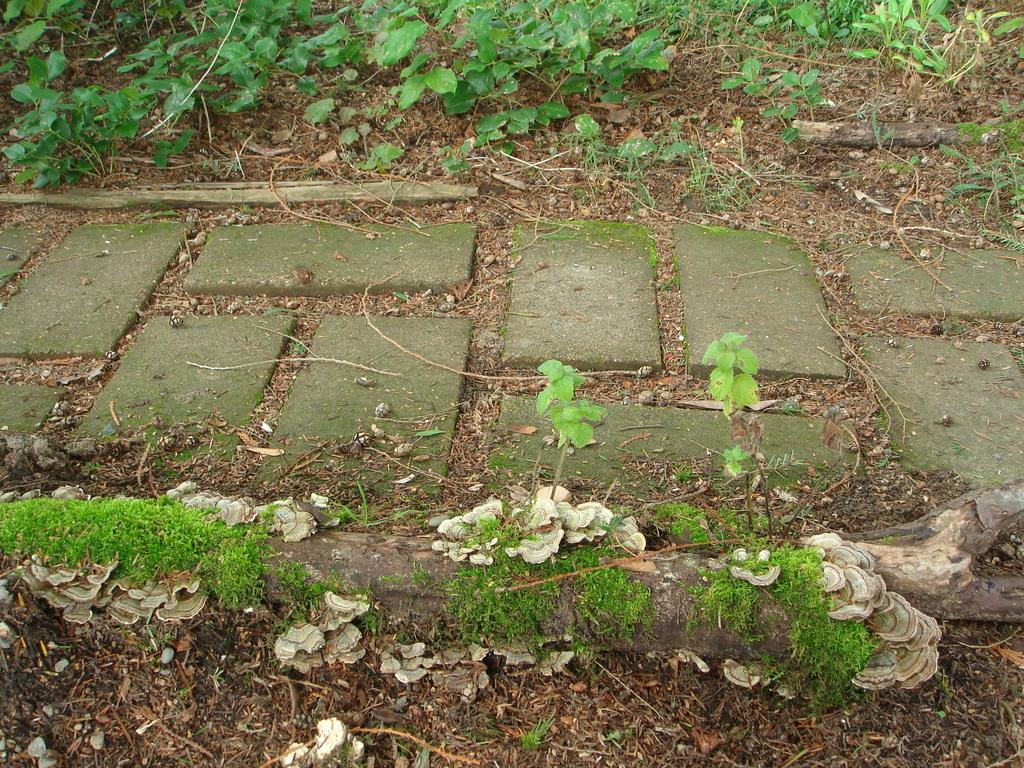What type of path is visible in the image? There is a walkway in the image. What can be seen growing in the image? There are plants in the image. What is present on the ground in the image? Dried leaves are present in the image. What type of fungi can be seen in the image? Oyster mushrooms are visible in the image. How many locks are visible on the walkway in the image? There are no locks visible on the walkway in the image. What type of dolls can be seen playing near the plants in the image? There are no dolls present in the image. 